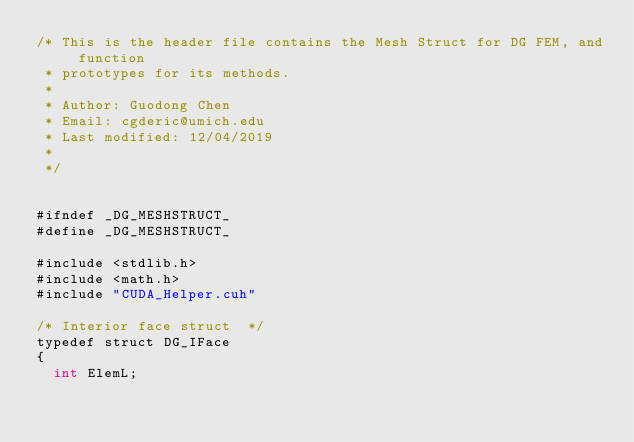Convert code to text. <code><loc_0><loc_0><loc_500><loc_500><_Cuda_>/* This is the header file contains the Mesh Struct for DG FEM, and function 
 * prototypes for its methods. 
 * 
 * Author: Guodong Chen
 * Email: cgderic@umich.edu
 * Last modified: 12/04/2019 
 *
 */


#ifndef _DG_MESHSTRUCT_
#define _DG_MESHSTRUCT_ 

#include <stdlib.h>
#include <math.h>
#include "CUDA_Helper.cuh"

/* Interior face struct  */
typedef struct DG_IFace 
{
  int ElemL;</code> 